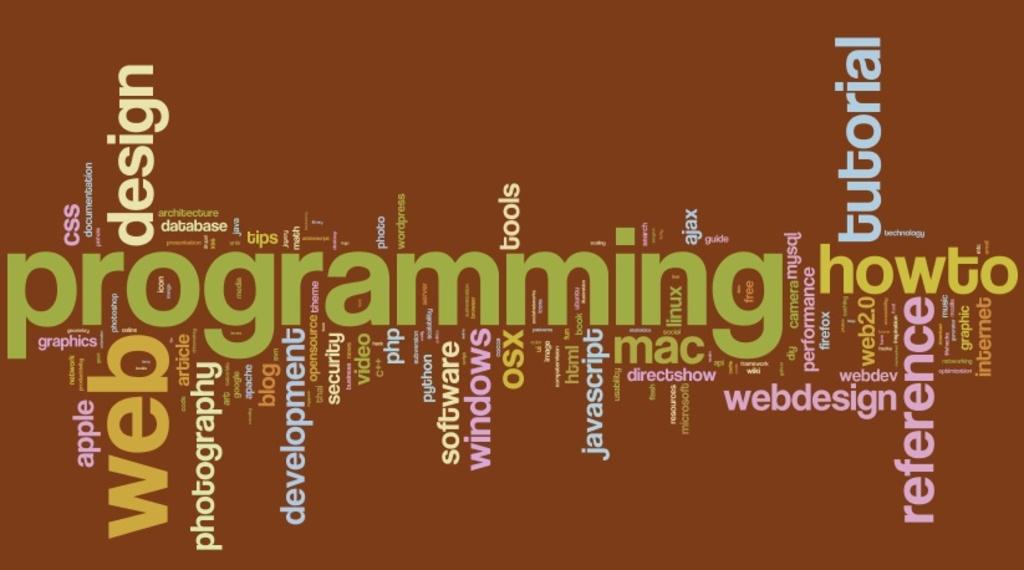What is the tutorial about?
Ensure brevity in your answer.  Programming. What is the largest word going across th middle of the picture?
Offer a very short reply. Programming. 